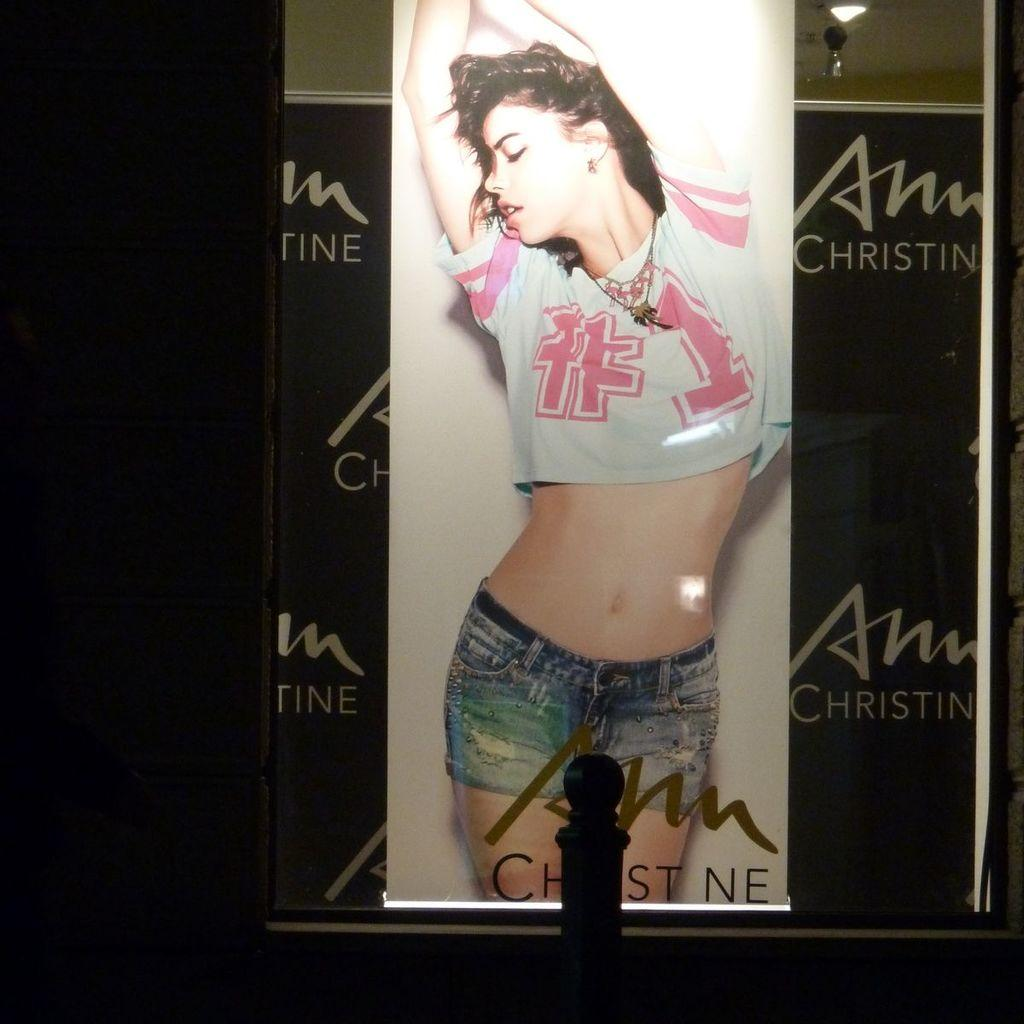<image>
Give a short and clear explanation of the subsequent image. A women is on an ad with Christin in the right upper corner. 